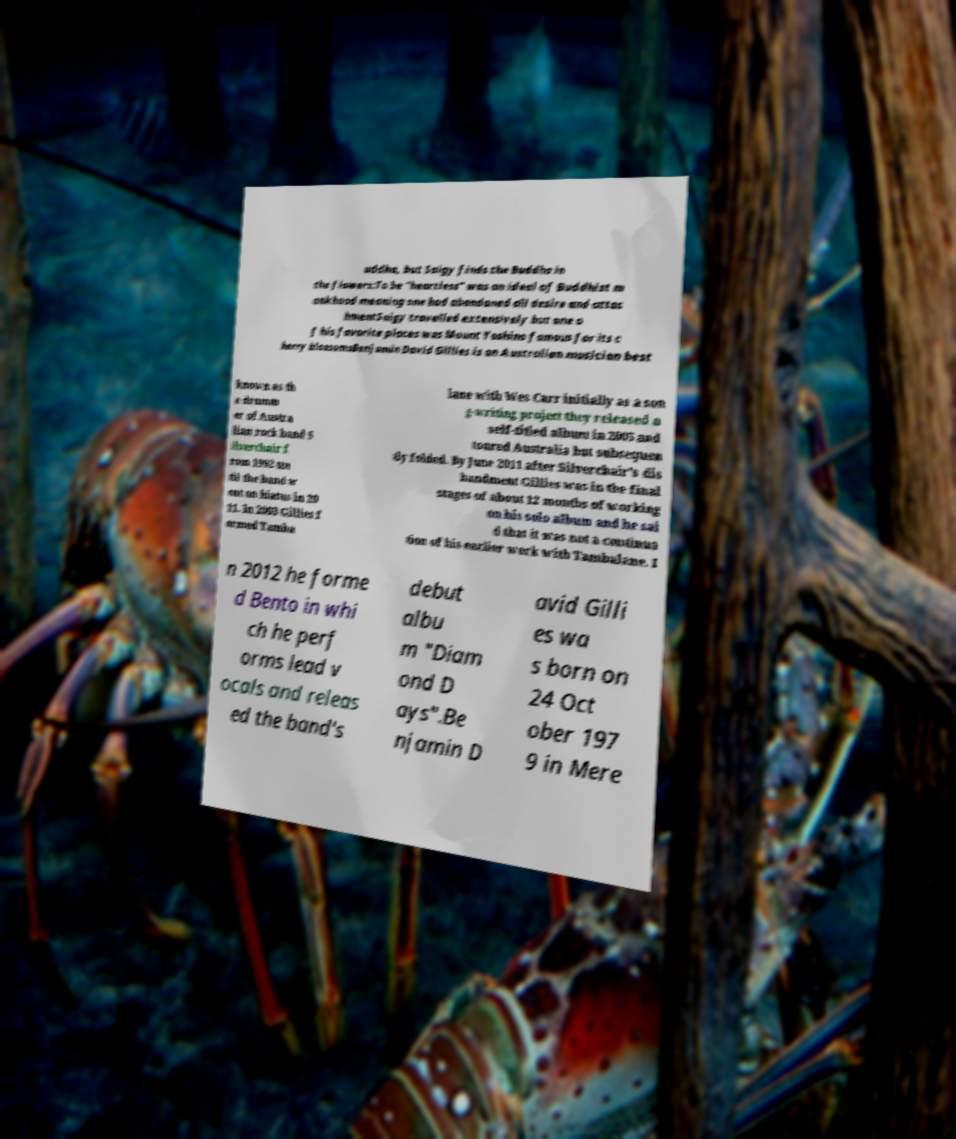Could you extract and type out the text from this image? uddha, but Saigy finds the Buddha in the flowers:To be "heartless" was an ideal of Buddhist m onkhood meaning one had abandoned all desire and attac hmentSaigy travelled extensively but one o f his favorite places was Mount Yoshino famous for its c herry blossomsBenjamin David Gillies is an Australian musician best known as th e drumm er of Austra lian rock band S ilverchair f rom 1992 un til the band w ent on hiatus in 20 11. In 2003 Gillies f ormed Tamba lane with Wes Carr initially as a son g-writing project they released a self-titled album in 2005 and toured Australia but subsequen tly folded. By June 2011 after Silverchair's dis bandment Gillies was in the final stages of about 12 months of working on his solo album and he sai d that it was not a continua tion of his earlier work with Tambalane. I n 2012 he forme d Bento in whi ch he perf orms lead v ocals and releas ed the band's debut albu m "Diam ond D ays".Be njamin D avid Gilli es wa s born on 24 Oct ober 197 9 in Mere 